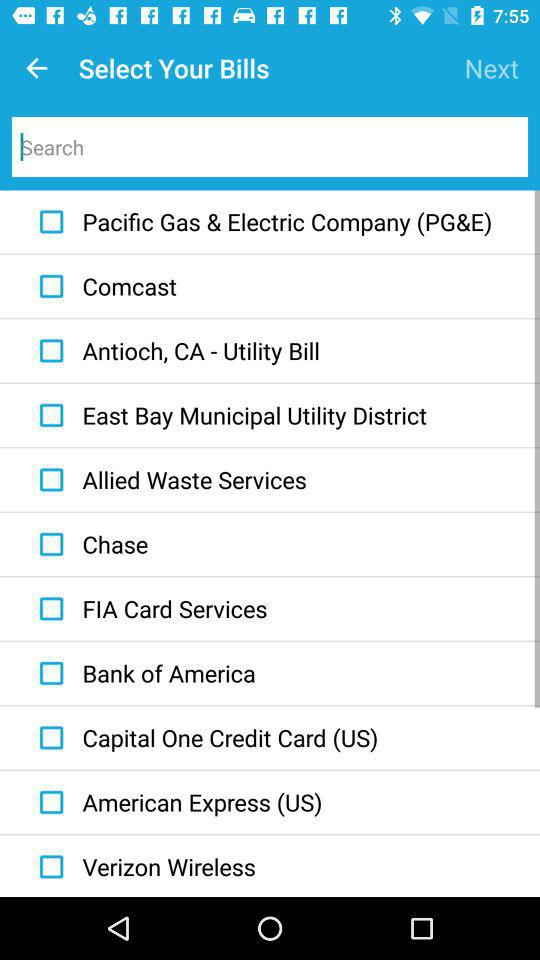What are the names of the different bills given? The name of the bills are "Pacific Gas & Electric Company (PG&E)", "Comcast", "Antioch, CA - Utility Bill", "East Bay Municipal Utility District", "Allied Waste Services", "Chase", "FIA Card Services", "Bank of America", "Capital One Credit Card (US)", "American Express (US)" and "Verizon Wireless". 